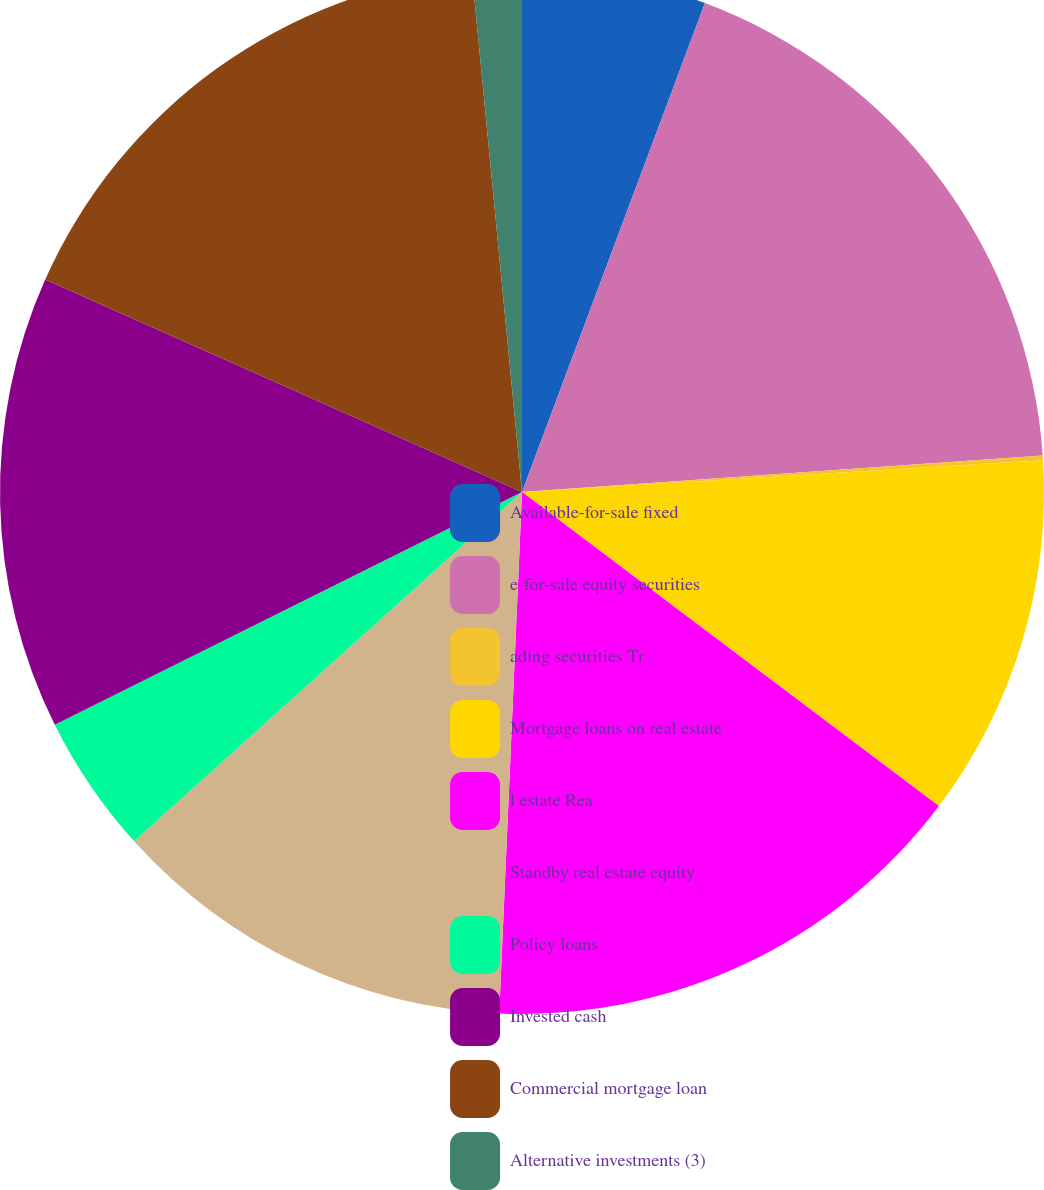Convert chart to OTSL. <chart><loc_0><loc_0><loc_500><loc_500><pie_chart><fcel>Available-for-sale fixed<fcel>e-for-sale equity securities<fcel>ading securities Tr<fcel>Mortgage loans on real estate<fcel>l estate Rea<fcel>Standby real estate equity<fcel>Policy loans<fcel>Invested cash<fcel>Commercial mortgage loan<fcel>Alternative investments (3)<nl><fcel>5.7%<fcel>18.19%<fcel>0.14%<fcel>11.25%<fcel>15.42%<fcel>12.64%<fcel>4.31%<fcel>14.03%<fcel>16.8%<fcel>1.53%<nl></chart> 